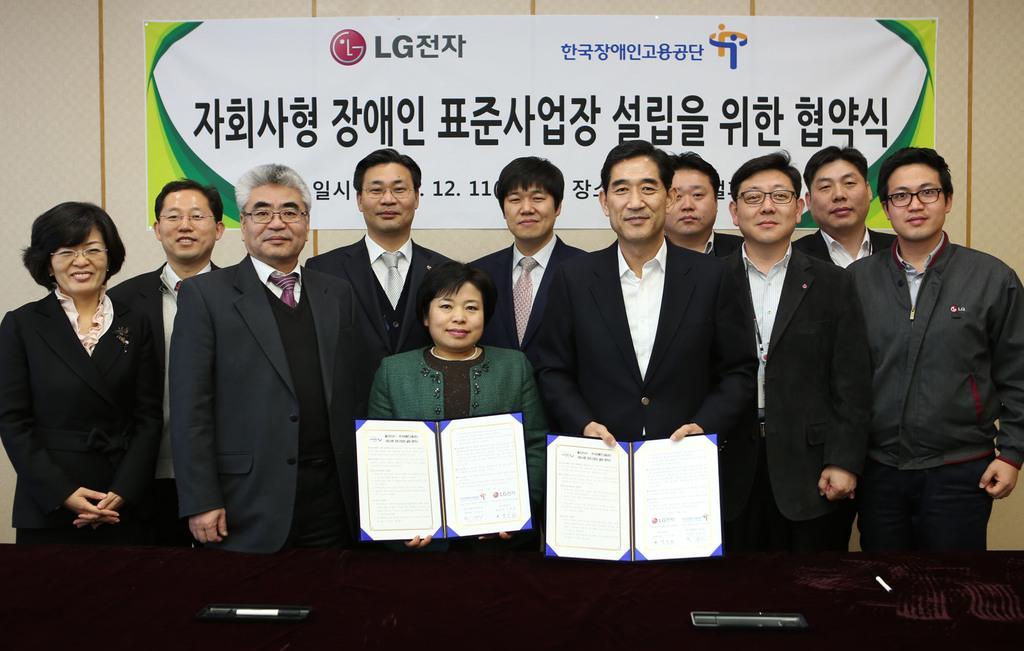In one or two sentences, can you explain what this image depicts? In the center of the picture there are men standing, they are wearing suits. In the foreground there are table and two people holding memorandum. In the background there is a banner attached to the wall. 